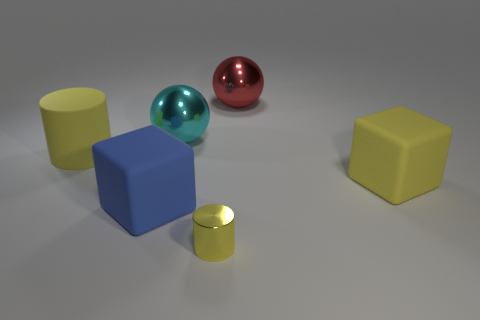Add 4 tiny objects. How many objects exist? 10 Subtract all spheres. How many objects are left? 4 Add 5 red objects. How many red objects exist? 6 Subtract all yellow cubes. How many cubes are left? 1 Subtract 0 green cubes. How many objects are left? 6 Subtract 2 balls. How many balls are left? 0 Subtract all blue cubes. Subtract all gray cylinders. How many cubes are left? 1 Subtract all yellow cubes. How many cyan spheres are left? 1 Subtract all blue matte cubes. Subtract all small shiny things. How many objects are left? 4 Add 4 large blue objects. How many large blue objects are left? 5 